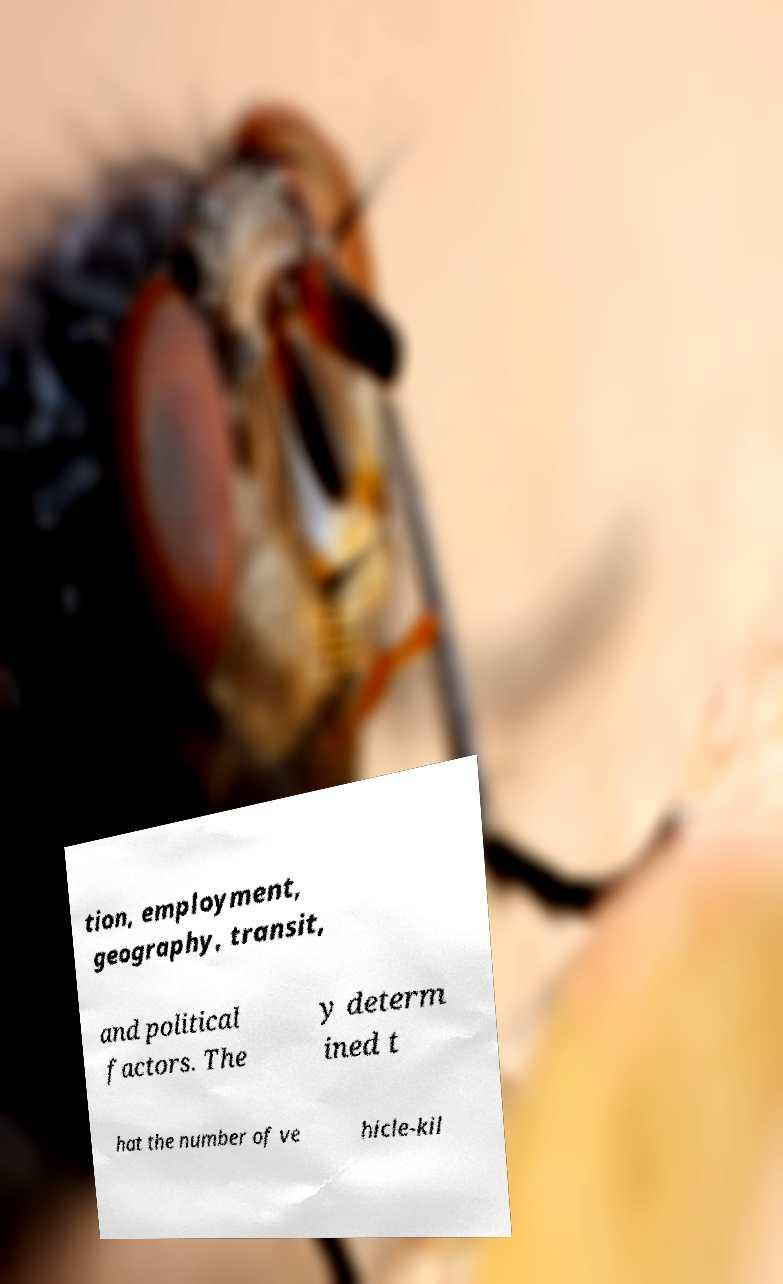Could you extract and type out the text from this image? tion, employment, geography, transit, and political factors. The y determ ined t hat the number of ve hicle-kil 